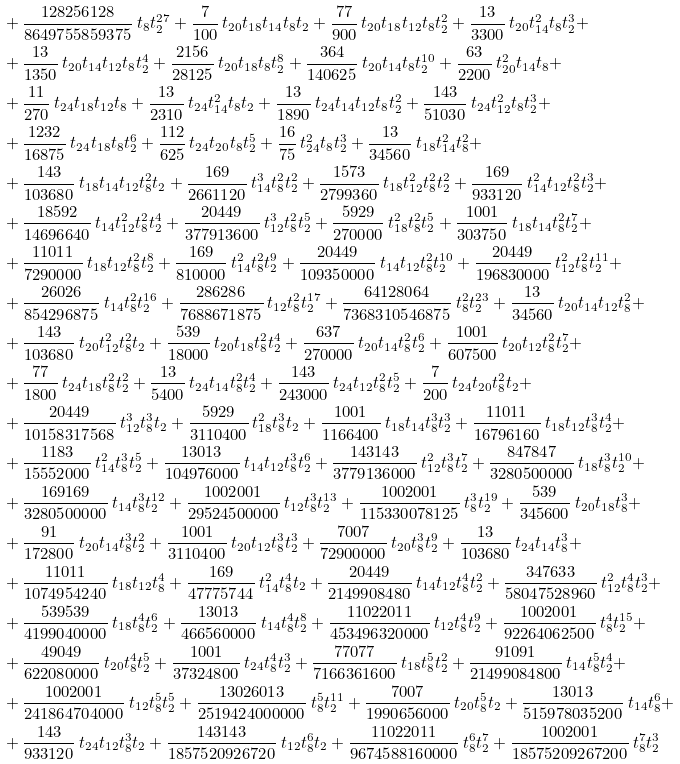Convert formula to latex. <formula><loc_0><loc_0><loc_500><loc_500>& + { \frac { 1 2 8 2 5 6 1 2 8 } { 8 6 4 9 7 5 5 8 5 9 3 7 5 } } \, t _ { 8 } t _ { 2 } ^ { 2 7 } + { \frac { 7 } { 1 0 0 } } \, t _ { 2 0 } t _ { 1 8 } t _ { 1 4 } t _ { 8 } t _ { 2 } + { \frac { 7 7 } { 9 0 0 } } \, t _ { 2 0 } t _ { 1 8 } t _ { 1 2 } t _ { 8 } t _ { 2 } ^ { 2 } + { \frac { 1 3 } { 3 3 0 0 } } \, t _ { 2 0 } t _ { 1 4 } ^ { 2 } t _ { 8 } t _ { 2 } ^ { 3 } + \\ & + { \frac { 1 3 } { 1 3 5 0 } } \, t _ { 2 0 } t _ { 1 4 } t _ { 1 2 } t _ { 8 } t _ { 2 } ^ { 4 } + { \frac { 2 1 5 6 } { 2 8 1 2 5 } } \, t _ { 2 0 } t _ { 1 8 } t _ { 8 } t _ { 2 } ^ { 8 } + { \frac { 3 6 4 } { 1 4 0 6 2 5 } } \, t _ { 2 0 } t _ { 1 4 } t _ { 8 } t _ { 2 } ^ { 1 0 } + { \frac { 6 3 } { 2 2 0 0 } } \, t _ { 2 0 } ^ { 2 } t _ { 1 4 } t _ { 8 } + \\ & + { \frac { 1 1 } { 2 7 0 } } \, t _ { 2 4 } t _ { 1 8 } t _ { 1 2 } t _ { 8 } + { \frac { 1 3 } { 2 3 1 0 } } \, t _ { 2 4 } t _ { 1 4 } ^ { 2 } t _ { 8 } t _ { 2 } + { \frac { 1 3 } { 1 8 9 0 } } \, t _ { 2 4 } t _ { 1 4 } t _ { 1 2 } t _ { 8 } t _ { 2 } ^ { 2 } + { \frac { 1 4 3 } { 5 1 0 3 0 } } \, t _ { 2 4 } t _ { 1 2 } ^ { 2 } t _ { 8 } t _ { 2 } ^ { 3 } + \\ & + { \frac { 1 2 3 2 } { 1 6 8 7 5 } } \, t _ { 2 4 } t _ { 1 8 } t _ { 8 } t _ { 2 } ^ { 6 } + { \frac { 1 1 2 } { 6 2 5 } } \, t _ { 2 4 } t _ { 2 0 } t _ { 8 } t _ { 2 } ^ { 5 } + { \frac { 1 6 } { 7 5 } } \, t _ { 2 4 } ^ { 2 } t _ { 8 } t _ { 2 } ^ { 3 } + { \frac { 1 3 } { 3 4 5 6 0 } } \, t _ { 1 8 } t _ { 1 4 } ^ { 2 } t _ { 8 } ^ { 2 } + \\ & + { \frac { 1 4 3 } { 1 0 3 6 8 0 } } \, t _ { 1 8 } t _ { 1 4 } t _ { 1 2 } t _ { 8 } ^ { 2 } t _ { 2 } + { \frac { 1 6 9 } { 2 6 6 1 1 2 0 } } \, t _ { 1 4 } ^ { 3 } t _ { 8 } ^ { 2 } t _ { 2 } ^ { 2 } + { \frac { 1 5 7 3 } { 2 7 9 9 3 6 0 } } \, t _ { 1 8 } t _ { 1 2 } ^ { 2 } t _ { 8 } ^ { 2 } t _ { 2 } ^ { 2 } + { \frac { 1 6 9 } { 9 3 3 1 2 0 } } \, t _ { 1 4 } ^ { 2 } t _ { 1 2 } t _ { 8 } ^ { 2 } t _ { 2 } ^ { 3 } + \\ & + { \frac { 1 8 5 9 2 } { 1 4 6 9 6 6 4 0 } } \, t _ { 1 4 } t _ { 1 2 } ^ { 2 } t _ { 8 } ^ { 2 } t _ { 2 } ^ { 4 } + { \frac { 2 0 4 4 9 } { 3 7 7 9 1 3 6 0 0 } } \, t _ { 1 2 } ^ { 3 } t _ { 8 } ^ { 2 } t _ { 2 } ^ { 5 } + { \frac { 5 9 2 9 } { 2 7 0 0 0 0 } } \, t _ { 1 8 } ^ { 2 } t _ { 8 } ^ { 2 } t _ { 2 } ^ { 5 } + { \frac { 1 0 0 1 } { 3 0 3 7 5 0 } } \, t _ { 1 8 } t _ { 1 4 } t _ { 8 } ^ { 2 } t _ { 2 } ^ { 7 } + \\ & + { \frac { 1 1 0 1 1 } { 7 2 9 0 0 0 0 } } \, t _ { 1 8 } t _ { 1 2 } t _ { 8 } ^ { 2 } t _ { 2 } ^ { 8 } + { \frac { 1 6 9 } { 8 1 0 0 0 0 } } \, t _ { 1 4 } ^ { 2 } t _ { 8 } ^ { 2 } t _ { 2 } ^ { 9 } + { \frac { 2 0 4 4 9 } { 1 0 9 3 5 0 0 0 0 } } \, t _ { 1 4 } t _ { 1 2 } t _ { 8 } ^ { 2 } t _ { 2 } ^ { 1 0 } + { \frac { 2 0 4 4 9 } { 1 9 6 8 3 0 0 0 0 } } \, t _ { 1 2 } ^ { 2 } t _ { 8 } ^ { 2 } t _ { 2 } ^ { 1 1 } + \\ & + { \frac { 2 6 0 2 6 } { 8 5 4 2 9 6 8 7 5 } } \, t _ { 1 4 } t _ { 8 } ^ { 2 } t _ { 2 } ^ { 1 6 } + { \frac { 2 8 6 2 8 6 } { 7 6 8 8 6 7 1 8 7 5 } } \, t _ { 1 2 } t _ { 8 } ^ { 2 } t _ { 2 } ^ { 1 7 } + { \frac { 6 4 1 2 8 0 6 4 } { 7 3 6 8 3 1 0 5 4 6 8 7 5 } } \, t _ { 8 } ^ { 2 } t _ { 2 } ^ { 2 3 } + { \frac { 1 3 } { 3 4 5 6 0 } } \, t _ { 2 0 } t _ { 1 4 } t _ { 1 2 } t _ { 8 } ^ { 2 } + \\ & + { \frac { 1 4 3 } { 1 0 3 6 8 0 } } \, t _ { 2 0 } t _ { 1 2 } ^ { 2 } t _ { 8 } ^ { 2 } t _ { 2 } + { \frac { 5 3 9 } { 1 8 0 0 0 } } \, t _ { 2 0 } t _ { 1 8 } t _ { 8 } ^ { 2 } t _ { 2 } ^ { 4 } + { \frac { 6 3 7 } { 2 7 0 0 0 0 } } \, t _ { 2 0 } t _ { 1 4 } t _ { 8 } ^ { 2 } t _ { 2 } ^ { 6 } + { \frac { 1 0 0 1 } { 6 0 7 5 0 0 } } \, t _ { 2 0 } t _ { 1 2 } t _ { 8 } ^ { 2 } t _ { 2 } ^ { 7 } + \\ & + { \frac { 7 7 } { 1 8 0 0 } } \, t _ { 2 4 } t _ { 1 8 } t _ { 8 } ^ { 2 } t _ { 2 } ^ { 2 } + { \frac { 1 3 } { 5 4 0 0 } } \, t _ { 2 4 } t _ { 1 4 } t _ { 8 } ^ { 2 } t _ { 2 } ^ { 4 } + { \frac { 1 4 3 } { 2 4 3 0 0 0 } } \, t _ { 2 4 } t _ { 1 2 } t _ { 8 } ^ { 2 } t _ { 2 } ^ { 5 } + { \frac { 7 } { 2 0 0 } } \, t _ { 2 4 } t _ { 2 0 } t _ { 8 } ^ { 2 } t _ { 2 } + \\ & + { \frac { 2 0 4 4 9 } { 1 0 1 5 8 3 1 7 5 6 8 } } \, t _ { 1 2 } ^ { 3 } t _ { 8 } ^ { 3 } t _ { 2 } + { \frac { 5 9 2 9 } { 3 1 1 0 4 0 0 } } \, t _ { 1 8 } ^ { 2 } t _ { 8 } ^ { 3 } t _ { 2 } + { \frac { 1 0 0 1 } { 1 1 6 6 4 0 0 } } \, t _ { 1 8 } t _ { 1 4 } t _ { 8 } ^ { 3 } t _ { 2 } ^ { 3 } + { \frac { 1 1 0 1 1 } { 1 6 7 9 6 1 6 0 } } \, t _ { 1 8 } t _ { 1 2 } t _ { 8 } ^ { 3 } t _ { 2 } ^ { 4 } + \\ & + { \frac { 1 1 8 3 } { 1 5 5 5 2 0 0 0 } } \, t _ { 1 4 } ^ { 2 } t _ { 8 } ^ { 3 } t _ { 2 } ^ { 5 } + { \frac { 1 3 0 1 3 } { 1 0 4 9 7 6 0 0 0 } } \, t _ { 1 4 } t _ { 1 2 } t _ { 8 } ^ { 3 } t _ { 2 } ^ { 6 } + { \frac { 1 4 3 1 4 3 } { 3 7 7 9 1 3 6 0 0 0 } } \, t _ { 1 2 } ^ { 2 } t _ { 8 } ^ { 3 } t _ { 2 } ^ { 7 } + { \frac { 8 4 7 8 4 7 } { 3 2 8 0 5 0 0 0 0 0 } } \, t _ { 1 8 } t _ { 8 } ^ { 3 } t _ { 2 } ^ { 1 0 } + \\ & + { \frac { 1 6 9 1 6 9 } { 3 2 8 0 5 0 0 0 0 0 } } \, t _ { 1 4 } t _ { 8 } ^ { 3 } t _ { 2 } ^ { 1 2 } + { \frac { 1 0 0 2 0 0 1 } { 2 9 5 2 4 5 0 0 0 0 0 } } \, t _ { 1 2 } t _ { 8 } ^ { 3 } t _ { 2 } ^ { 1 3 } + { \frac { 1 0 0 2 0 0 1 } { 1 1 5 3 3 0 0 7 8 1 2 5 } } \, t _ { 8 } ^ { 3 } t _ { 2 } ^ { 1 9 } + { \frac { 5 3 9 } { 3 4 5 6 0 0 } } \, t _ { 2 0 } t _ { 1 8 } t _ { 8 } ^ { 3 } + \\ & + { \frac { 9 1 } { 1 7 2 8 0 0 } } \, t _ { 2 0 } t _ { 1 4 } t _ { 8 } ^ { 3 } t _ { 2 } ^ { 2 } + { \frac { 1 0 0 1 } { 3 1 1 0 4 0 0 } } \, t _ { 2 0 } t _ { 1 2 } t _ { 8 } ^ { 3 } t _ { 2 } ^ { 3 } + { \frac { 7 0 0 7 } { 7 2 9 0 0 0 0 0 } } \, t _ { 2 0 } t _ { 8 } ^ { 3 } t _ { 2 } ^ { 9 } + { \frac { 1 3 } { 1 0 3 6 8 0 } } \, t _ { 2 4 } t _ { 1 4 } t _ { 8 } ^ { 3 } + \\ & + { \frac { 1 1 0 1 1 } { 1 0 7 4 9 5 4 2 4 0 } } \, t _ { 1 8 } t _ { 1 2 } t _ { 8 } ^ { 4 } + { \frac { 1 6 9 } { 4 7 7 7 5 7 4 4 } } \, t _ { 1 4 } ^ { 2 } t _ { 8 } ^ { 4 } t _ { 2 } + { \frac { 2 0 4 4 9 } { 2 1 4 9 9 0 8 4 8 0 } } \, t _ { 1 4 } t _ { 1 2 } t _ { 8 } ^ { 4 } t _ { 2 } ^ { 2 } + { \frac { 3 4 7 6 3 3 } { 5 8 0 4 7 5 2 8 9 6 0 } } \, t _ { 1 2 } ^ { 2 } t _ { 8 } ^ { 4 } t _ { 2 } ^ { 3 } + \\ & + { \frac { 5 3 9 5 3 9 } { 4 1 9 9 0 4 0 0 0 0 } } \, t _ { 1 8 } t _ { 8 } ^ { 4 } t _ { 2 } ^ { 6 } + { \frac { 1 3 0 1 3 } { 4 6 6 5 6 0 0 0 0 } } \, t _ { 1 4 } t _ { 8 } ^ { 4 } t _ { 2 } ^ { 8 } + { \frac { 1 1 0 2 2 0 1 1 } { 4 5 3 4 9 6 3 2 0 0 0 0 } } \, t _ { 1 2 } t _ { 8 } ^ { 4 } t _ { 2 } ^ { 9 } + { \frac { 1 0 0 2 0 0 1 } { 9 2 2 6 4 0 6 2 5 0 0 } } \, t _ { 8 } ^ { 4 } t _ { 2 } ^ { 1 5 } + \\ & + { \frac { 4 9 0 4 9 } { 6 2 2 0 8 0 0 0 0 } } \, t _ { 2 0 } t _ { 8 } ^ { 4 } t _ { 2 } ^ { 5 } + { \frac { 1 0 0 1 } { 3 7 3 2 4 8 0 0 } } \, t _ { 2 4 } t _ { 8 } ^ { 4 } t _ { 2 } ^ { 3 } + { \frac { 7 7 0 7 7 } { 7 1 6 6 3 6 1 6 0 0 } } \, t _ { 1 8 } t _ { 8 } ^ { 5 } t _ { 2 } ^ { 2 } + { \frac { 9 1 0 9 1 } { 2 1 4 9 9 0 8 4 8 0 0 } } \, t _ { 1 4 } t _ { 8 } ^ { 5 } t _ { 2 } ^ { 4 } + \\ & + { \frac { 1 0 0 2 0 0 1 } { 2 4 1 8 6 4 7 0 4 0 0 0 } } \, t _ { 1 2 } t _ { 8 } ^ { 5 } t _ { 2 } ^ { 5 } + { \frac { 1 3 0 2 6 0 1 3 } { 2 5 1 9 4 2 4 0 0 0 0 0 0 } } \, t _ { 8 } ^ { 5 } t _ { 2 } ^ { 1 1 } + { \frac { 7 0 0 7 } { 1 9 9 0 6 5 6 0 0 0 } } \, t _ { 2 0 } t _ { 8 } ^ { 5 } t _ { 2 } + { \frac { 1 3 0 1 3 } { 5 1 5 9 7 8 0 3 5 2 0 0 } } \, t _ { 1 4 } t _ { 8 } ^ { 6 } + \\ & + { \frac { 1 4 3 } { 9 3 3 1 2 0 } } \, t _ { 2 4 } t _ { 1 2 } t _ { 8 } ^ { 3 } t _ { 2 } + { \frac { 1 4 3 1 4 3 } { 1 8 5 7 5 2 0 9 2 6 7 2 0 } } \, t _ { 1 2 } t _ { 8 } ^ { 6 } t _ { 2 } + { \frac { 1 1 0 2 2 0 1 1 } { 9 6 7 4 5 8 8 1 6 0 0 0 0 } } \, t _ { 8 } ^ { 6 } t _ { 2 } ^ { 7 } + { \frac { 1 0 0 2 0 0 1 } { 1 8 5 7 5 2 0 9 2 6 7 2 0 0 } } \, t _ { 8 } ^ { 7 } t _ { 2 } ^ { 3 }</formula> 